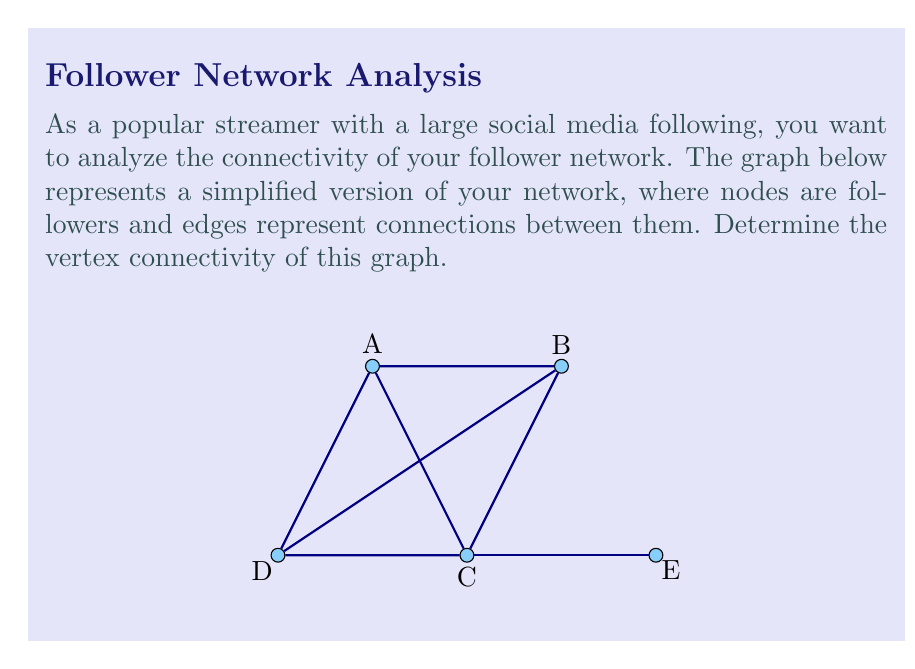Give your solution to this math problem. To determine the vertex connectivity of the graph, we need to find the minimum number of vertices that need to be removed to disconnect the graph. Let's approach this step-by-step:

1) First, let's recall the definition of vertex connectivity:
   The vertex connectivity $\kappa(G)$ of a graph $G$ is the minimum number of vertices whose removal results in a disconnected graph or a trivial graph.

2) Examine the graph:
   - It has 5 vertices (A, B, C, D, E)
   - E is connected only to C, making it a potential cut vertex

3) Let's consider removing vertices:
   - Removing C disconnects E from the rest of the graph
   - Removing any single vertex other than C does not disconnect the graph

4) Therefore, removing just one vertex (C) is sufficient to disconnect the graph

5) We can verify that removing any other single vertex doesn't disconnect the graph:
   - Remove A: B-C-D-E remains connected
   - Remove B: A-C-D-E remains connected
   - Remove D: A-B-C-E remains connected
   - Remove E: A-B-C-D remains connected

6) Since removing one vertex (C) disconnects the graph, and no smaller number of vertices can do so, the vertex connectivity of this graph is 1.
Answer: $\kappa(G) = 1$ 